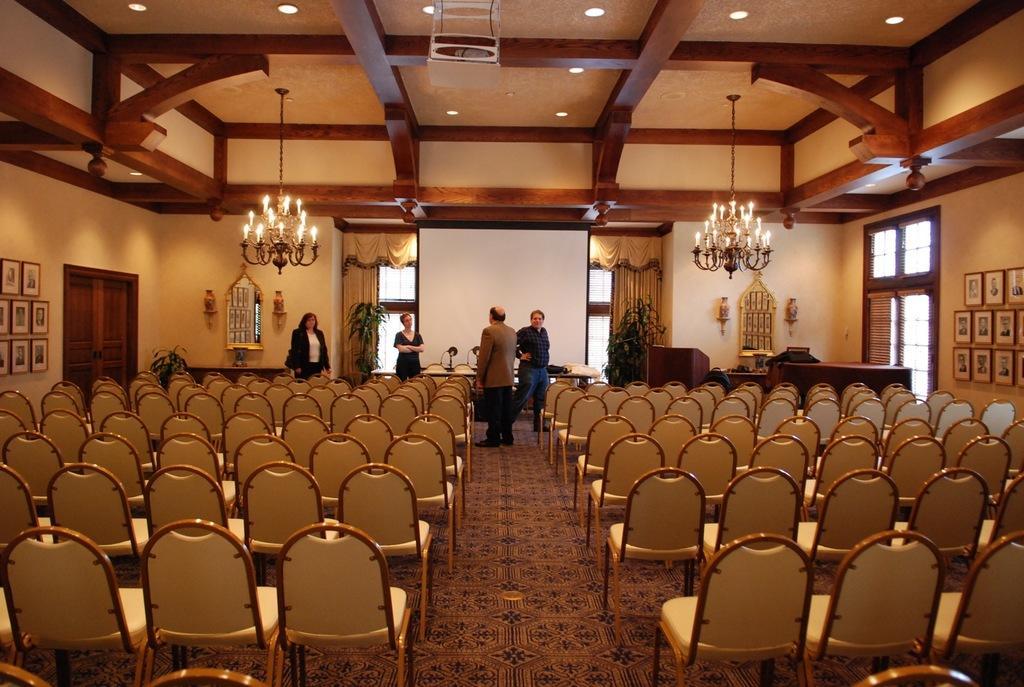Can you describe this image briefly? In this image I can see four persons standing. I can see few chairs. On either side of the image I can see few photo frames on the wall. In the middle of the image I can see a projector. At the top I can see lights hanged to the ceiling. 